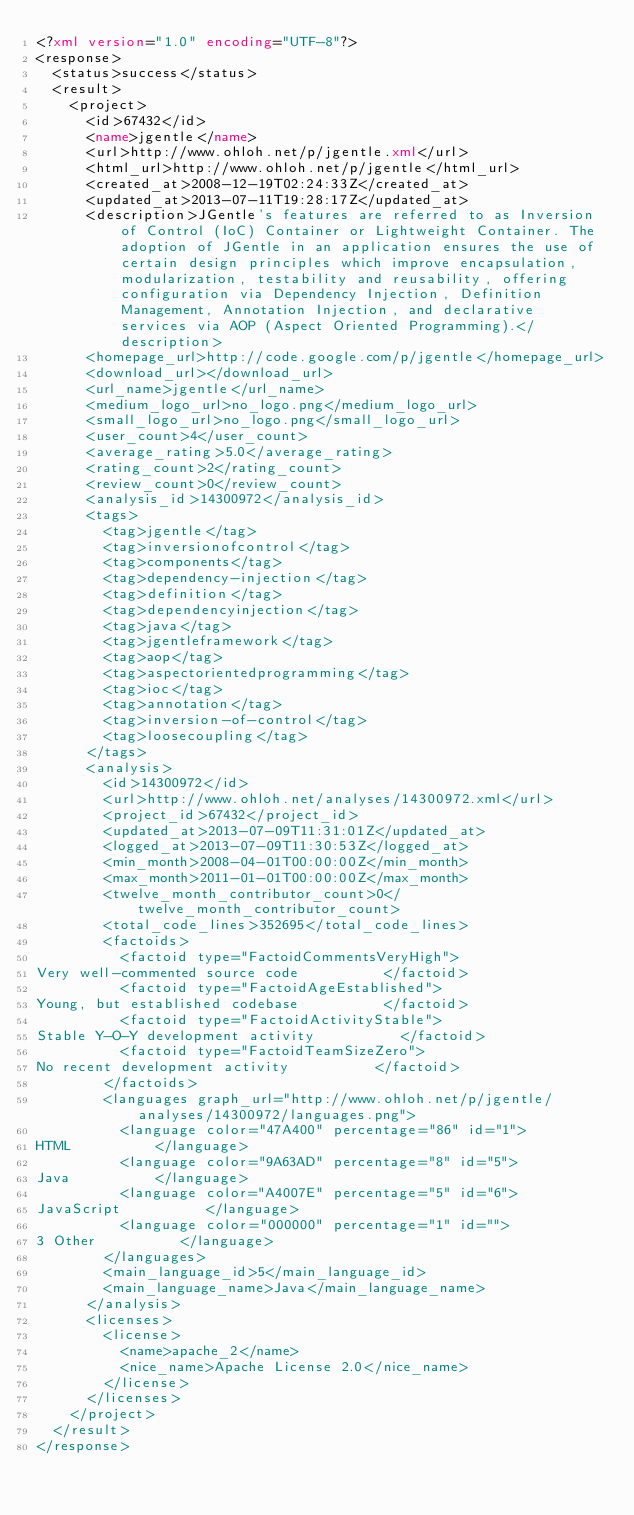Convert code to text. <code><loc_0><loc_0><loc_500><loc_500><_XML_><?xml version="1.0" encoding="UTF-8"?>
<response>
  <status>success</status>
  <result>
    <project>
      <id>67432</id>
      <name>jgentle</name>
      <url>http://www.ohloh.net/p/jgentle.xml</url>
      <html_url>http://www.ohloh.net/p/jgentle</html_url>
      <created_at>2008-12-19T02:24:33Z</created_at>
      <updated_at>2013-07-11T19:28:17Z</updated_at>
      <description>JGentle's features are referred to as Inversion of Control (IoC) Container or Lightweight Container. The adoption of JGentle in an application ensures the use of certain design principles which improve encapsulation, modularization, testability and reusability, offering configuration via Dependency Injection, Definition Management, Annotation Injection, and declarative services via AOP (Aspect Oriented Programming).</description>
      <homepage_url>http://code.google.com/p/jgentle</homepage_url>
      <download_url></download_url>
      <url_name>jgentle</url_name>
      <medium_logo_url>no_logo.png</medium_logo_url>
      <small_logo_url>no_logo.png</small_logo_url>
      <user_count>4</user_count>
      <average_rating>5.0</average_rating>
      <rating_count>2</rating_count>
      <review_count>0</review_count>
      <analysis_id>14300972</analysis_id>
      <tags>
        <tag>jgentle</tag>
        <tag>inversionofcontrol</tag>
        <tag>components</tag>
        <tag>dependency-injection</tag>
        <tag>definition</tag>
        <tag>dependencyinjection</tag>
        <tag>java</tag>
        <tag>jgentleframework</tag>
        <tag>aop</tag>
        <tag>aspectorientedprogramming</tag>
        <tag>ioc</tag>
        <tag>annotation</tag>
        <tag>inversion-of-control</tag>
        <tag>loosecoupling</tag>
      </tags>
      <analysis>
        <id>14300972</id>
        <url>http://www.ohloh.net/analyses/14300972.xml</url>
        <project_id>67432</project_id>
        <updated_at>2013-07-09T11:31:01Z</updated_at>
        <logged_at>2013-07-09T11:30:53Z</logged_at>
        <min_month>2008-04-01T00:00:00Z</min_month>
        <max_month>2011-01-01T00:00:00Z</max_month>
        <twelve_month_contributor_count>0</twelve_month_contributor_count>
        <total_code_lines>352695</total_code_lines>
        <factoids>
          <factoid type="FactoidCommentsVeryHigh">
Very well-commented source code          </factoid>
          <factoid type="FactoidAgeEstablished">
Young, but established codebase          </factoid>
          <factoid type="FactoidActivityStable">
Stable Y-O-Y development activity          </factoid>
          <factoid type="FactoidTeamSizeZero">
No recent development activity          </factoid>
        </factoids>
        <languages graph_url="http://www.ohloh.net/p/jgentle/analyses/14300972/languages.png">
          <language color="47A400" percentage="86" id="1">
HTML          </language>
          <language color="9A63AD" percentage="8" id="5">
Java          </language>
          <language color="A4007E" percentage="5" id="6">
JavaScript          </language>
          <language color="000000" percentage="1" id="">
3 Other          </language>
        </languages>
        <main_language_id>5</main_language_id>
        <main_language_name>Java</main_language_name>
      </analysis>
      <licenses>
        <license>
          <name>apache_2</name>
          <nice_name>Apache License 2.0</nice_name>
        </license>
      </licenses>
    </project>
  </result>
</response>
</code> 